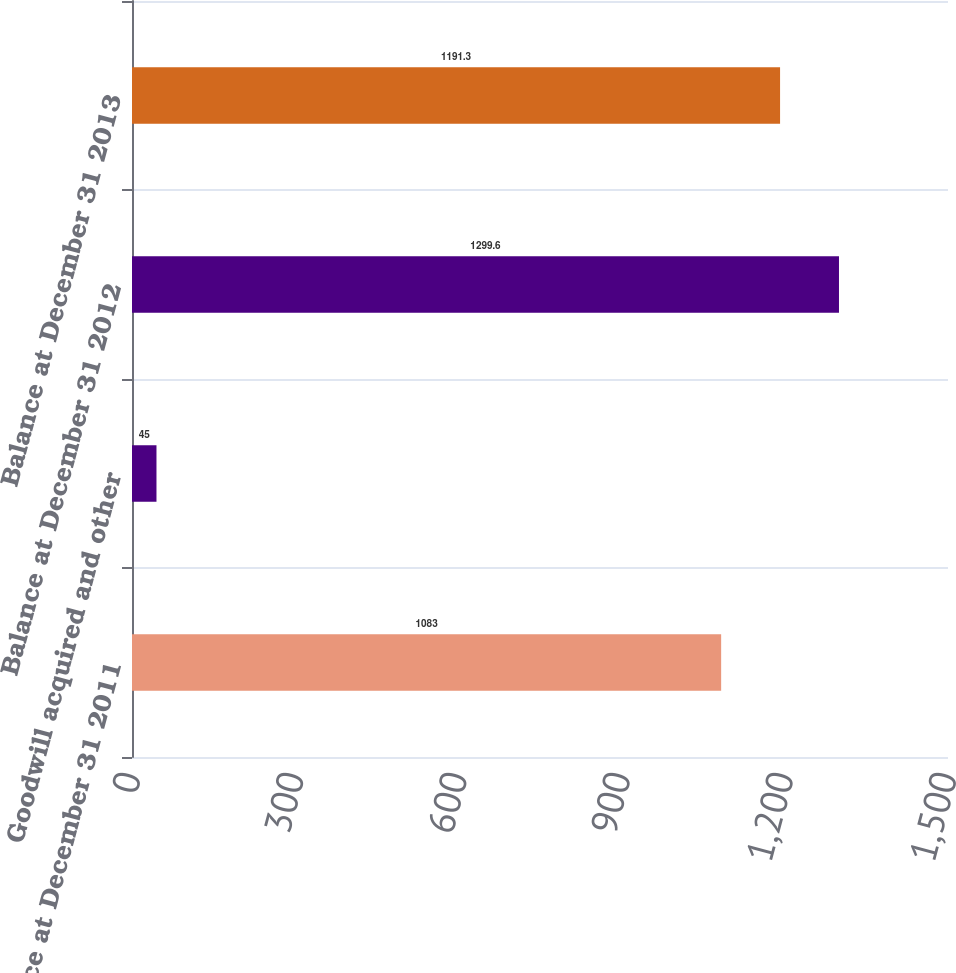Convert chart. <chart><loc_0><loc_0><loc_500><loc_500><bar_chart><fcel>Balance at December 31 2011<fcel>Goodwill acquired and other<fcel>Balance at December 31 2012<fcel>Balance at December 31 2013<nl><fcel>1083<fcel>45<fcel>1299.6<fcel>1191.3<nl></chart> 